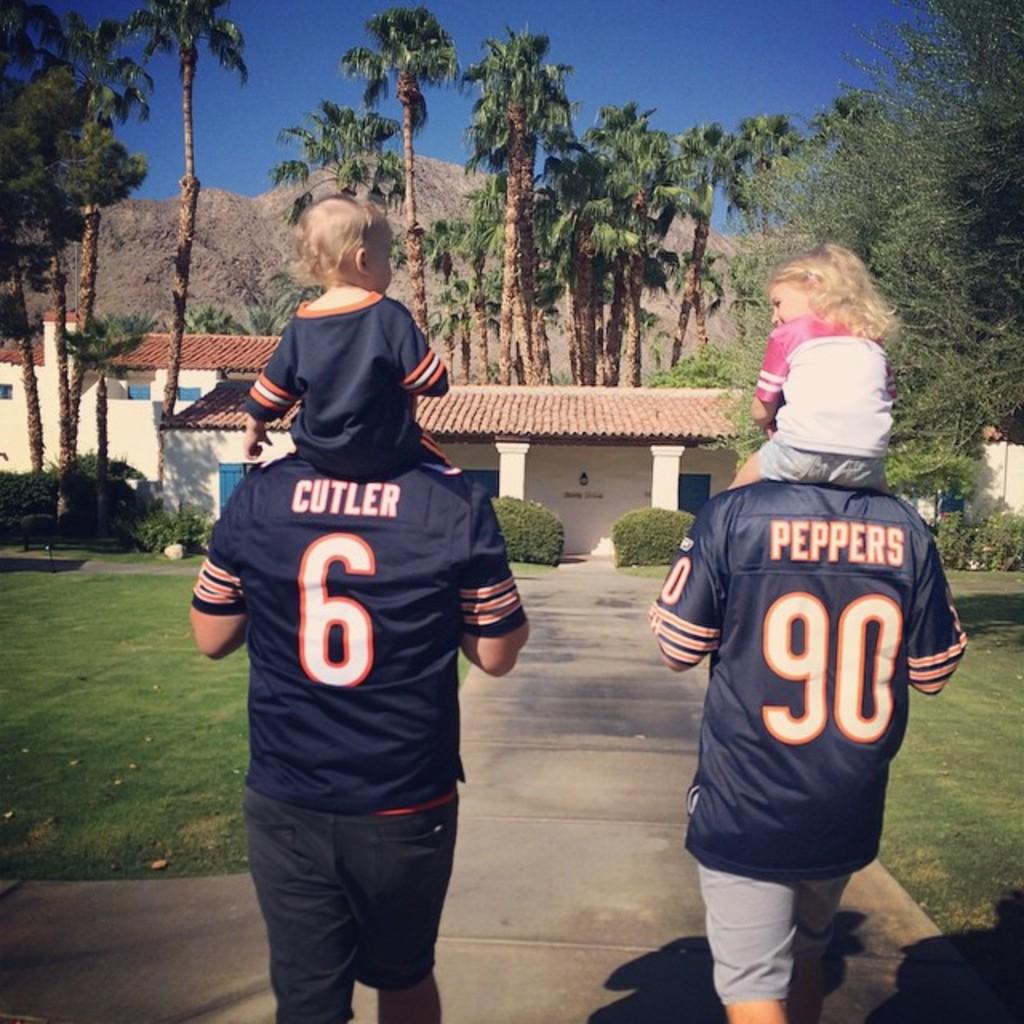What name is on the jersey above the number "90"?
Offer a terse response. Peppers. What jersey number is on the right?
Provide a succinct answer. 90. 